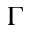<formula> <loc_0><loc_0><loc_500><loc_500>\Gamma</formula> 